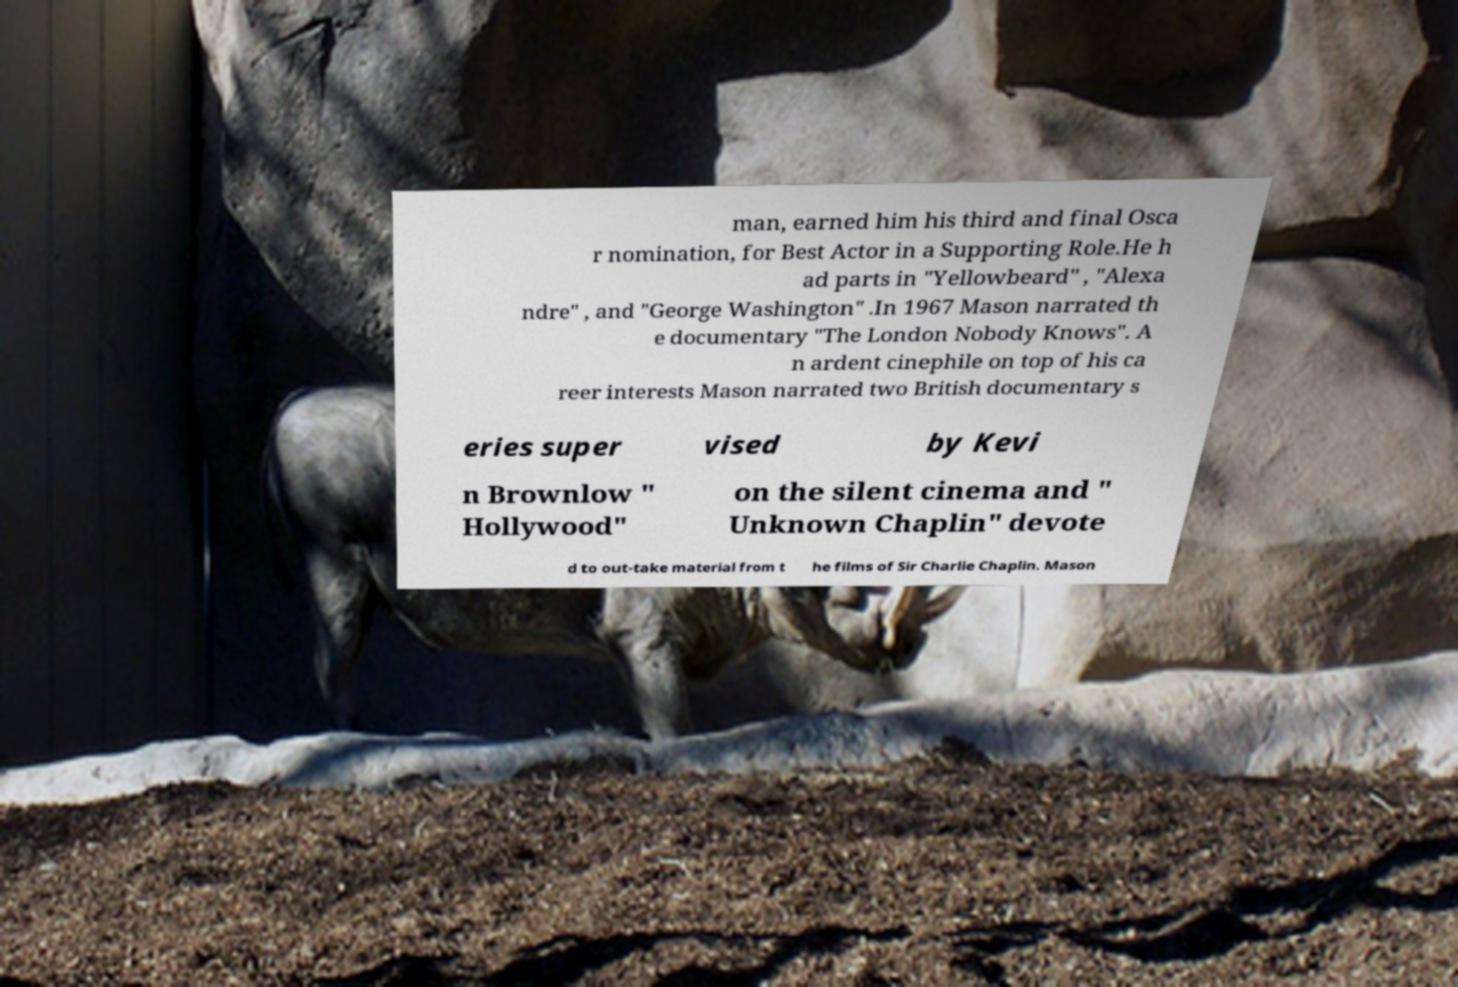Please identify and transcribe the text found in this image. man, earned him his third and final Osca r nomination, for Best Actor in a Supporting Role.He h ad parts in "Yellowbeard" , "Alexa ndre" , and "George Washington" .In 1967 Mason narrated th e documentary "The London Nobody Knows". A n ardent cinephile on top of his ca reer interests Mason narrated two British documentary s eries super vised by Kevi n Brownlow " Hollywood" on the silent cinema and " Unknown Chaplin" devote d to out-take material from t he films of Sir Charlie Chaplin. Mason 